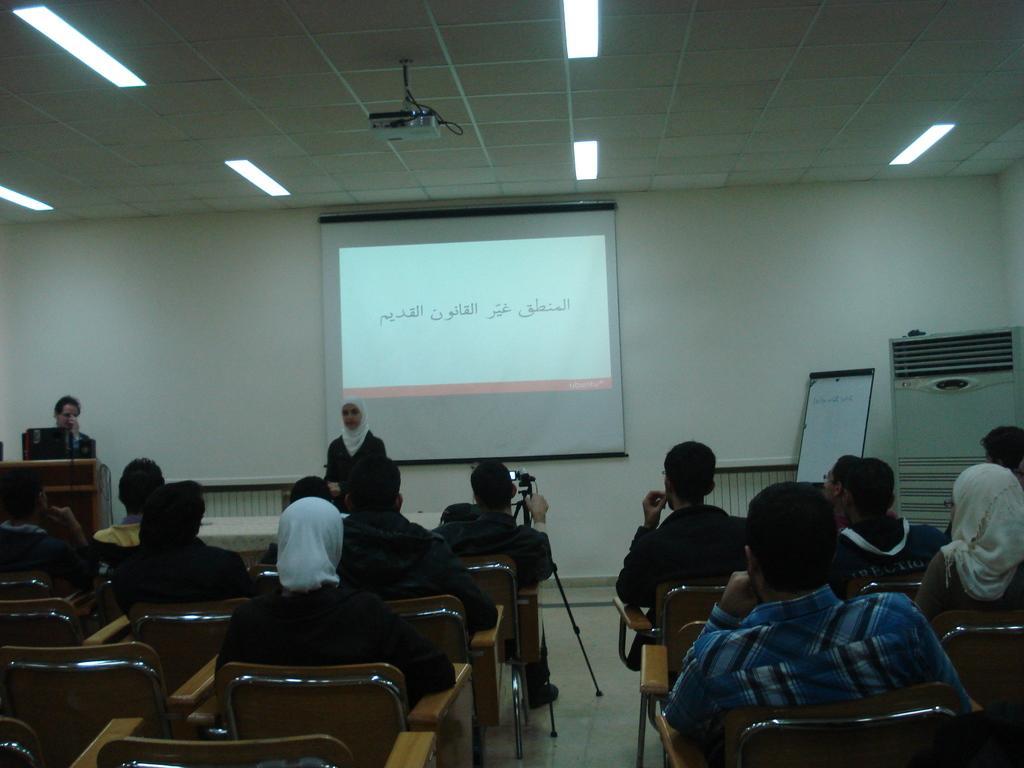How would you summarize this image in a sentence or two? In this picture we can see some persons are sitting on the chairs. This is floor. Here we can see a person who is standing on the floor. On the background there is a screen and this is wall. These are the lights and there is a board. 